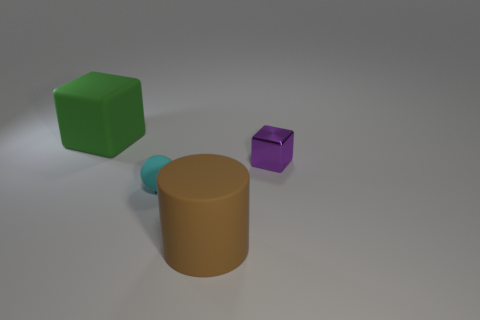Add 4 tiny spheres. How many objects exist? 8 Subtract all cylinders. How many objects are left? 3 Add 1 tiny yellow metal objects. How many tiny yellow metal objects exist? 1 Subtract 0 green cylinders. How many objects are left? 4 Subtract all tiny objects. Subtract all cyan balls. How many objects are left? 1 Add 3 metallic cubes. How many metallic cubes are left? 4 